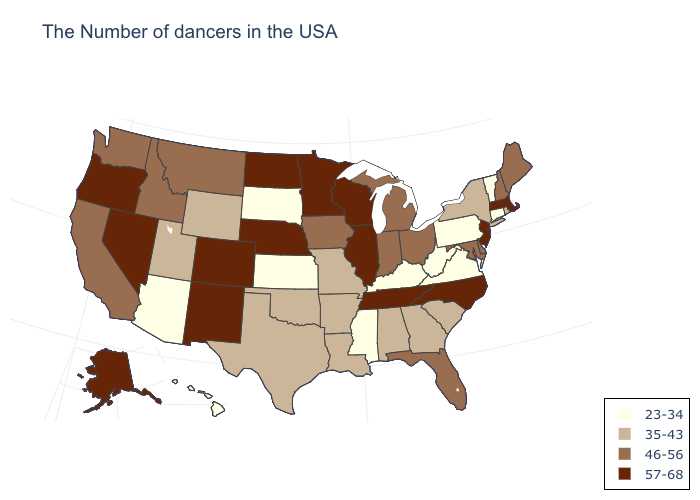Does Massachusetts have the highest value in the USA?
Quick response, please. Yes. Does the map have missing data?
Answer briefly. No. Name the states that have a value in the range 57-68?
Short answer required. Massachusetts, New Jersey, North Carolina, Tennessee, Wisconsin, Illinois, Minnesota, Nebraska, North Dakota, Colorado, New Mexico, Nevada, Oregon, Alaska. Does Missouri have the same value as Delaware?
Be succinct. No. Name the states that have a value in the range 46-56?
Concise answer only. Maine, New Hampshire, Delaware, Maryland, Ohio, Florida, Michigan, Indiana, Iowa, Montana, Idaho, California, Washington. Name the states that have a value in the range 57-68?
Give a very brief answer. Massachusetts, New Jersey, North Carolina, Tennessee, Wisconsin, Illinois, Minnesota, Nebraska, North Dakota, Colorado, New Mexico, Nevada, Oregon, Alaska. Which states have the lowest value in the USA?
Concise answer only. Vermont, Connecticut, Pennsylvania, Virginia, West Virginia, Kentucky, Mississippi, Kansas, South Dakota, Arizona, Hawaii. Name the states that have a value in the range 46-56?
Concise answer only. Maine, New Hampshire, Delaware, Maryland, Ohio, Florida, Michigan, Indiana, Iowa, Montana, Idaho, California, Washington. Name the states that have a value in the range 57-68?
Quick response, please. Massachusetts, New Jersey, North Carolina, Tennessee, Wisconsin, Illinois, Minnesota, Nebraska, North Dakota, Colorado, New Mexico, Nevada, Oregon, Alaska. What is the value of California?
Give a very brief answer. 46-56. How many symbols are there in the legend?
Be succinct. 4. What is the value of Idaho?
Write a very short answer. 46-56. What is the value of Nebraska?
Write a very short answer. 57-68. Which states have the lowest value in the USA?
Give a very brief answer. Vermont, Connecticut, Pennsylvania, Virginia, West Virginia, Kentucky, Mississippi, Kansas, South Dakota, Arizona, Hawaii. 